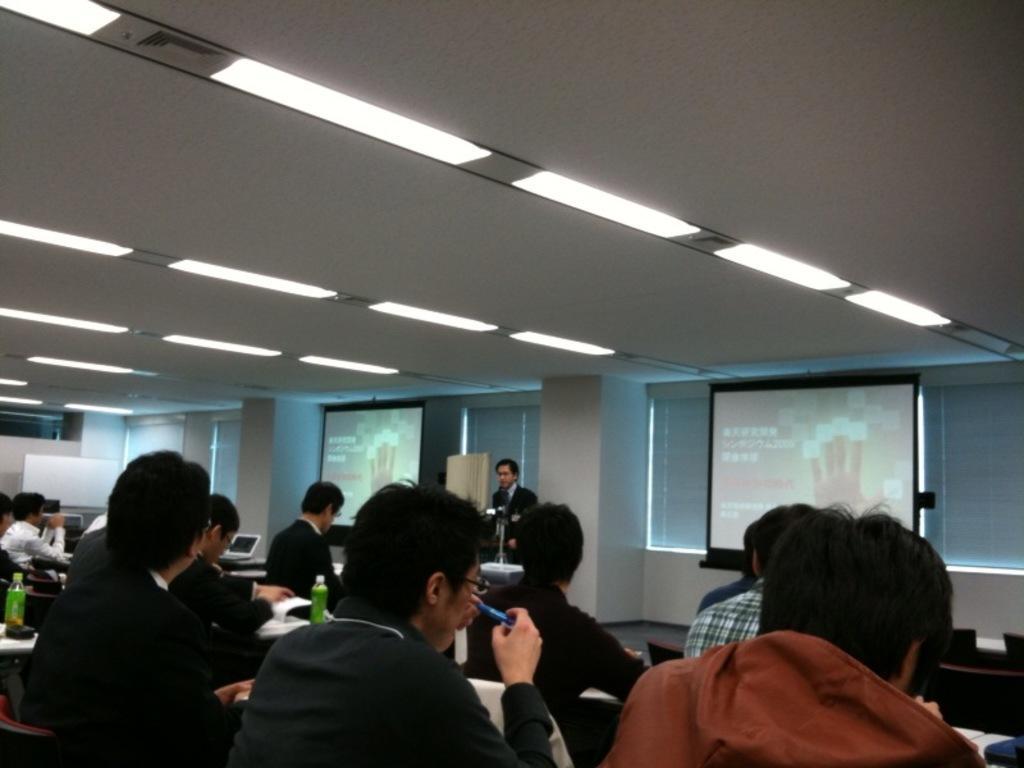How would you summarize this image in a sentence or two? In this image I can see there are few persons sitting on chair and one person standing in front of the beam there are few screens attached to the wall in the middle ,at the top few lights attached to the roof, on tables I can see bottles. 